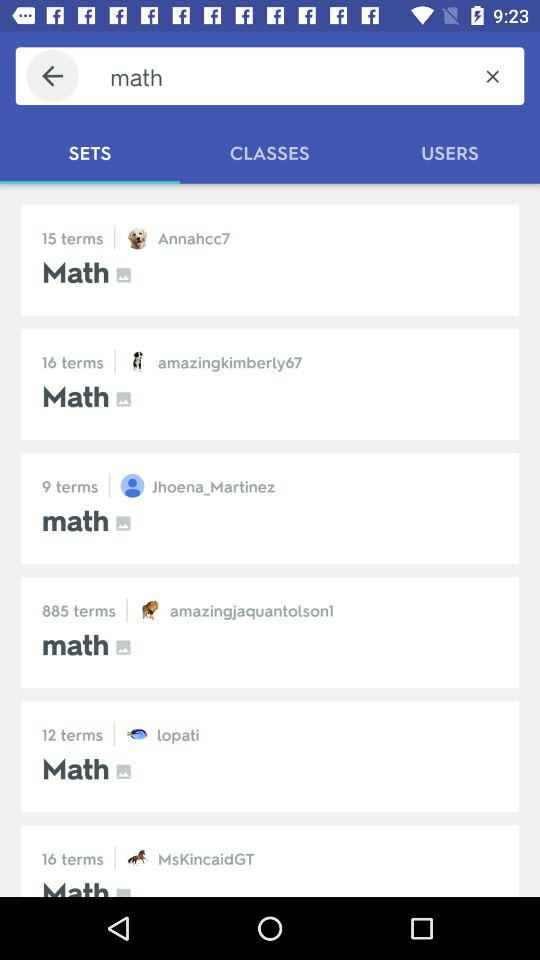Who is in 16 terms?
When the provided information is insufficient, respond with <no answer>. <no answer> 